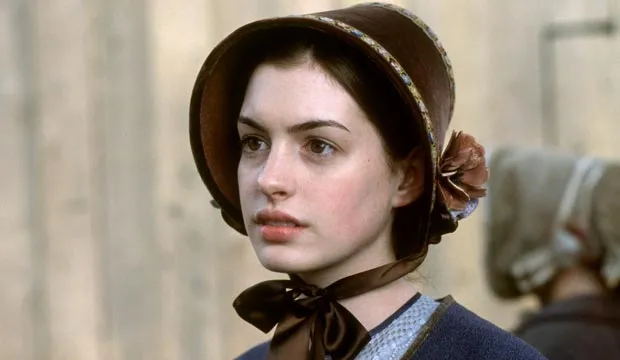Can you describe the historical setting this character might belong to? The character in the image appears to be from the Regency era, characterized by the early 19th century. This period is known for its distinctive fashion, including bonnets, high-waisted dresses, and elaborate accessories. The stone building in the background could be indicative of a setting in England, where much of the architecture of the time featured stone masonry and classical designs. What kind of emotions do you think the character is experiencing? The character seems to be exhibiting a contemplative or possibly melancholic expression. Her sideways glance and serious demeanor might suggest she is deep in thought, perhaps reflecting on a significant event or decision. The composition of the image, including the blurred background figure, adds to the mood of introspection. 